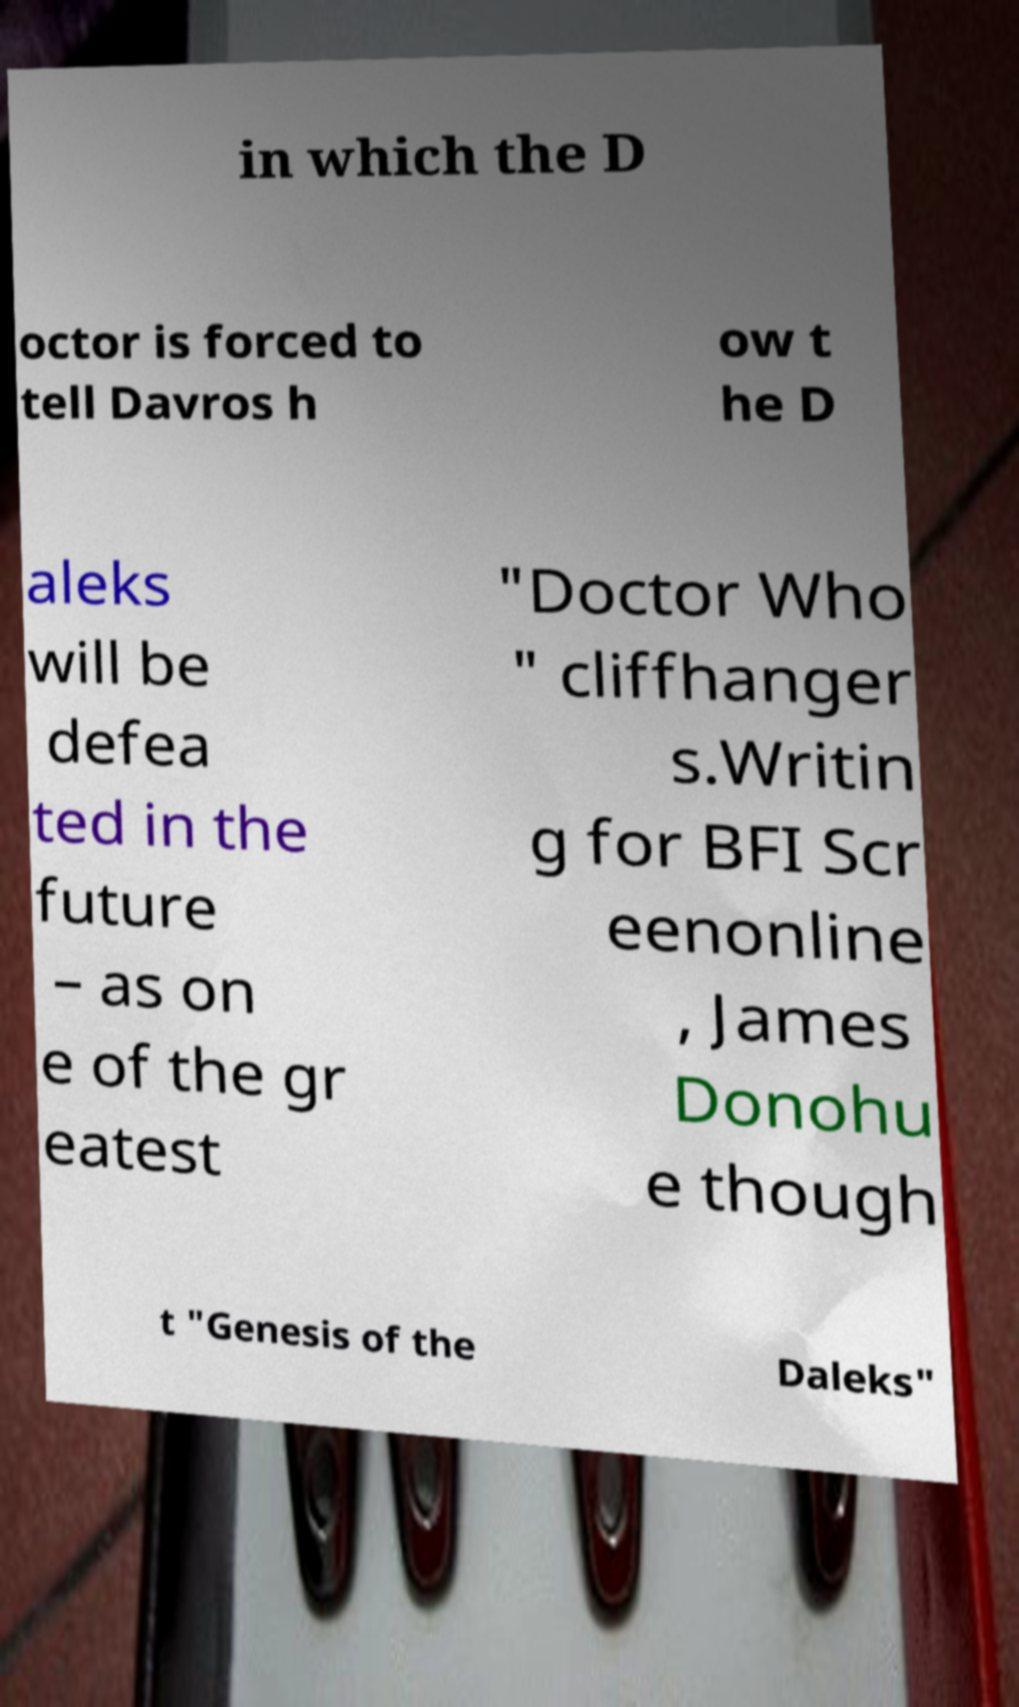Can you accurately transcribe the text from the provided image for me? in which the D octor is forced to tell Davros h ow t he D aleks will be defea ted in the future – as on e of the gr eatest "Doctor Who " cliffhanger s.Writin g for BFI Scr eenonline , James Donohu e though t "Genesis of the Daleks" 